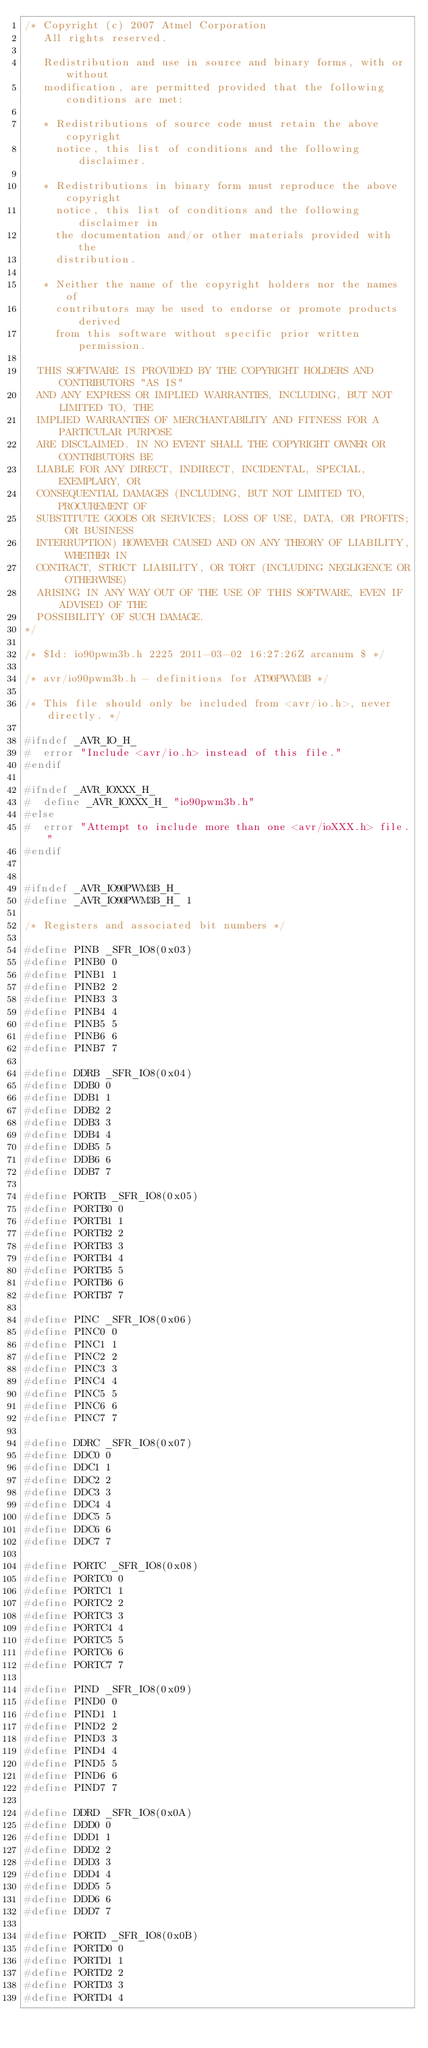Convert code to text. <code><loc_0><loc_0><loc_500><loc_500><_C_>/* Copyright (c) 2007 Atmel Corporation
   All rights reserved.

   Redistribution and use in source and binary forms, with or without
   modification, are permitted provided that the following conditions are met:

   * Redistributions of source code must retain the above copyright
     notice, this list of conditions and the following disclaimer.

   * Redistributions in binary form must reproduce the above copyright
     notice, this list of conditions and the following disclaimer in
     the documentation and/or other materials provided with the
     distribution.

   * Neither the name of the copyright holders nor the names of
     contributors may be used to endorse or promote products derived
     from this software without specific prior written permission.

  THIS SOFTWARE IS PROVIDED BY THE COPYRIGHT HOLDERS AND CONTRIBUTORS "AS IS"
  AND ANY EXPRESS OR IMPLIED WARRANTIES, INCLUDING, BUT NOT LIMITED TO, THE
  IMPLIED WARRANTIES OF MERCHANTABILITY AND FITNESS FOR A PARTICULAR PURPOSE
  ARE DISCLAIMED. IN NO EVENT SHALL THE COPYRIGHT OWNER OR CONTRIBUTORS BE
  LIABLE FOR ANY DIRECT, INDIRECT, INCIDENTAL, SPECIAL, EXEMPLARY, OR
  CONSEQUENTIAL DAMAGES (INCLUDING, BUT NOT LIMITED TO, PROCUREMENT OF
  SUBSTITUTE GOODS OR SERVICES; LOSS OF USE, DATA, OR PROFITS; OR BUSINESS
  INTERRUPTION) HOWEVER CAUSED AND ON ANY THEORY OF LIABILITY, WHETHER IN
  CONTRACT, STRICT LIABILITY, OR TORT (INCLUDING NEGLIGENCE OR OTHERWISE)
  ARISING IN ANY WAY OUT OF THE USE OF THIS SOFTWARE, EVEN IF ADVISED OF THE
  POSSIBILITY OF SUCH DAMAGE.
*/

/* $Id: io90pwm3b.h 2225 2011-03-02 16:27:26Z arcanum $ */

/* avr/io90pwm3b.h - definitions for AT90PWM3B */

/* This file should only be included from <avr/io.h>, never directly. */

#ifndef _AVR_IO_H_
#  error "Include <avr/io.h> instead of this file."
#endif

#ifndef _AVR_IOXXX_H_
#  define _AVR_IOXXX_H_ "io90pwm3b.h"
#else
#  error "Attempt to include more than one <avr/ioXXX.h> file."
#endif


#ifndef _AVR_IO90PWM3B_H_
#define _AVR_IO90PWM3B_H_ 1

/* Registers and associated bit numbers */

#define PINB _SFR_IO8(0x03)
#define PINB0 0
#define PINB1 1
#define PINB2 2
#define PINB3 3
#define PINB4 4
#define PINB5 5
#define PINB6 6
#define PINB7 7

#define DDRB _SFR_IO8(0x04)
#define DDB0 0
#define DDB1 1
#define DDB2 2
#define DDB3 3
#define DDB4 4
#define DDB5 5
#define DDB6 6
#define DDB7 7

#define PORTB _SFR_IO8(0x05)
#define PORTB0 0
#define PORTB1 1
#define PORTB2 2
#define PORTB3 3
#define PORTB4 4
#define PORTB5 5
#define PORTB6 6
#define PORTB7 7

#define PINC _SFR_IO8(0x06)
#define PINC0 0
#define PINC1 1
#define PINC2 2
#define PINC3 3
#define PINC4 4
#define PINC5 5
#define PINC6 6
#define PINC7 7

#define DDRC _SFR_IO8(0x07)
#define DDC0 0
#define DDC1 1
#define DDC2 2
#define DDC3 3
#define DDC4 4
#define DDC5 5
#define DDC6 6
#define DDC7 7

#define PORTC _SFR_IO8(0x08)
#define PORTC0 0
#define PORTC1 1
#define PORTC2 2
#define PORTC3 3
#define PORTC4 4
#define PORTC5 5
#define PORTC6 6
#define PORTC7 7

#define PIND _SFR_IO8(0x09)
#define PIND0 0
#define PIND1 1
#define PIND2 2
#define PIND3 3
#define PIND4 4
#define PIND5 5
#define PIND6 6
#define PIND7 7

#define DDRD _SFR_IO8(0x0A)
#define DDD0 0
#define DDD1 1
#define DDD2 2
#define DDD3 3
#define DDD4 4
#define DDD5 5
#define DDD6 6
#define DDD7 7

#define PORTD _SFR_IO8(0x0B)
#define PORTD0 0
#define PORTD1 1
#define PORTD2 2
#define PORTD3 3
#define PORTD4 4</code> 